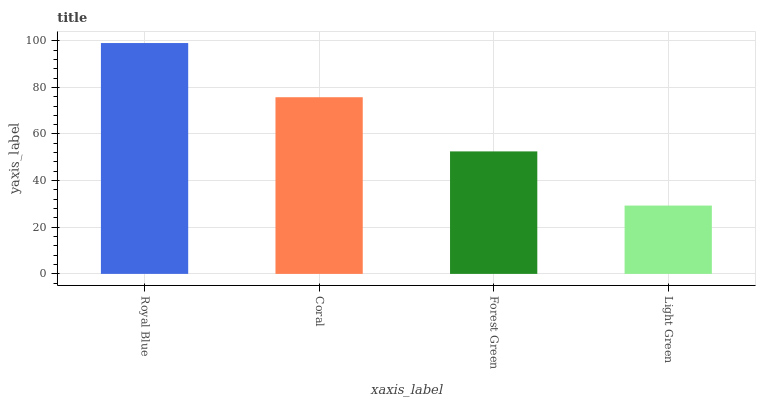Is Light Green the minimum?
Answer yes or no. Yes. Is Royal Blue the maximum?
Answer yes or no. Yes. Is Coral the minimum?
Answer yes or no. No. Is Coral the maximum?
Answer yes or no. No. Is Royal Blue greater than Coral?
Answer yes or no. Yes. Is Coral less than Royal Blue?
Answer yes or no. Yes. Is Coral greater than Royal Blue?
Answer yes or no. No. Is Royal Blue less than Coral?
Answer yes or no. No. Is Coral the high median?
Answer yes or no. Yes. Is Forest Green the low median?
Answer yes or no. Yes. Is Royal Blue the high median?
Answer yes or no. No. Is Light Green the low median?
Answer yes or no. No. 